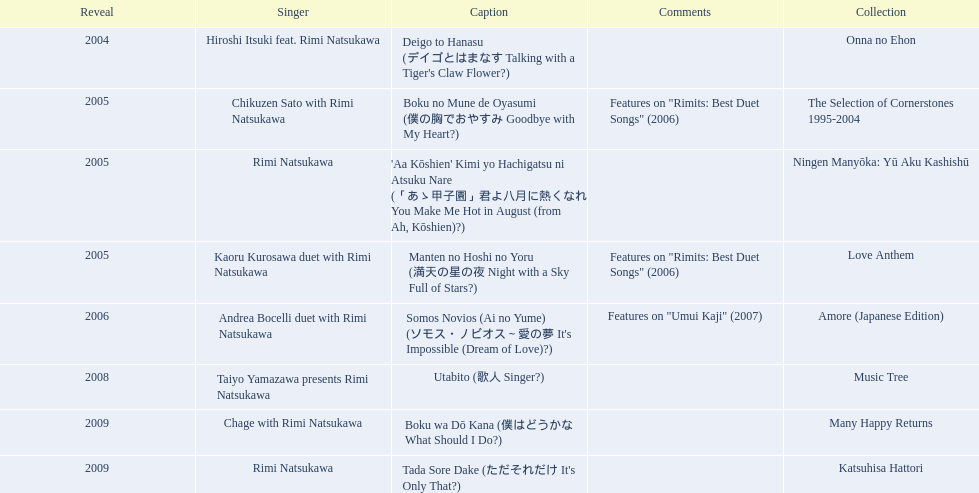What year was onna no ehon released? 2004. What year was music tree released? 2008. Which of the two was not released in 2004? Music Tree. 